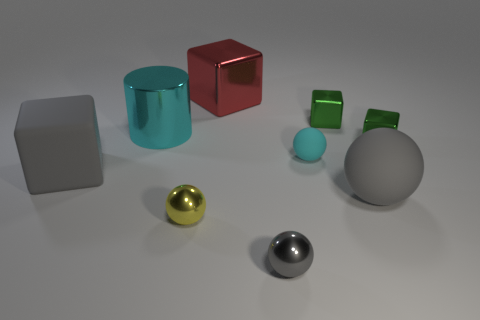How many other things are made of the same material as the large cyan cylinder?
Your response must be concise. 5. Is the big sphere the same color as the rubber block?
Provide a succinct answer. Yes. Is the number of small shiny things that are behind the small gray metal thing less than the number of shiny objects that are behind the tiny cyan rubber sphere?
Offer a very short reply. Yes. There is a large rubber thing that is the same shape as the gray metallic object; what is its color?
Offer a terse response. Gray. There is a green cube that is in front of the metal cylinder; does it have the same size as the small cyan thing?
Your response must be concise. Yes. Are there fewer small things behind the large cylinder than rubber cubes?
Keep it short and to the point. No. What size is the rubber ball that is in front of the big gray object on the left side of the cyan matte thing?
Make the answer very short. Large. Is there anything else that is the same shape as the cyan shiny thing?
Your answer should be compact. No. Is the number of tiny green metal objects less than the number of metal blocks?
Make the answer very short. Yes. The large object that is both behind the gray block and in front of the red cube is made of what material?
Your response must be concise. Metal. 